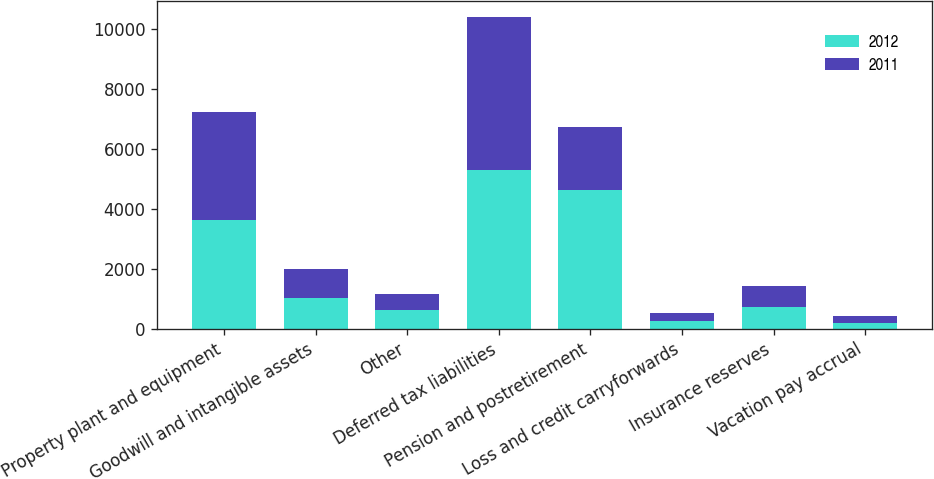Convert chart. <chart><loc_0><loc_0><loc_500><loc_500><stacked_bar_chart><ecel><fcel>Property plant and equipment<fcel>Goodwill and intangible assets<fcel>Other<fcel>Deferred tax liabilities<fcel>Pension and postretirement<fcel>Loss and credit carryforwards<fcel>Insurance reserves<fcel>Vacation pay accrual<nl><fcel>2012<fcel>3624<fcel>1035<fcel>617<fcel>5276<fcel>4608<fcel>258<fcel>737<fcel>209<nl><fcel>2011<fcel>3607<fcel>951<fcel>554<fcel>5112<fcel>2106<fcel>259<fcel>696<fcel>208<nl></chart> 